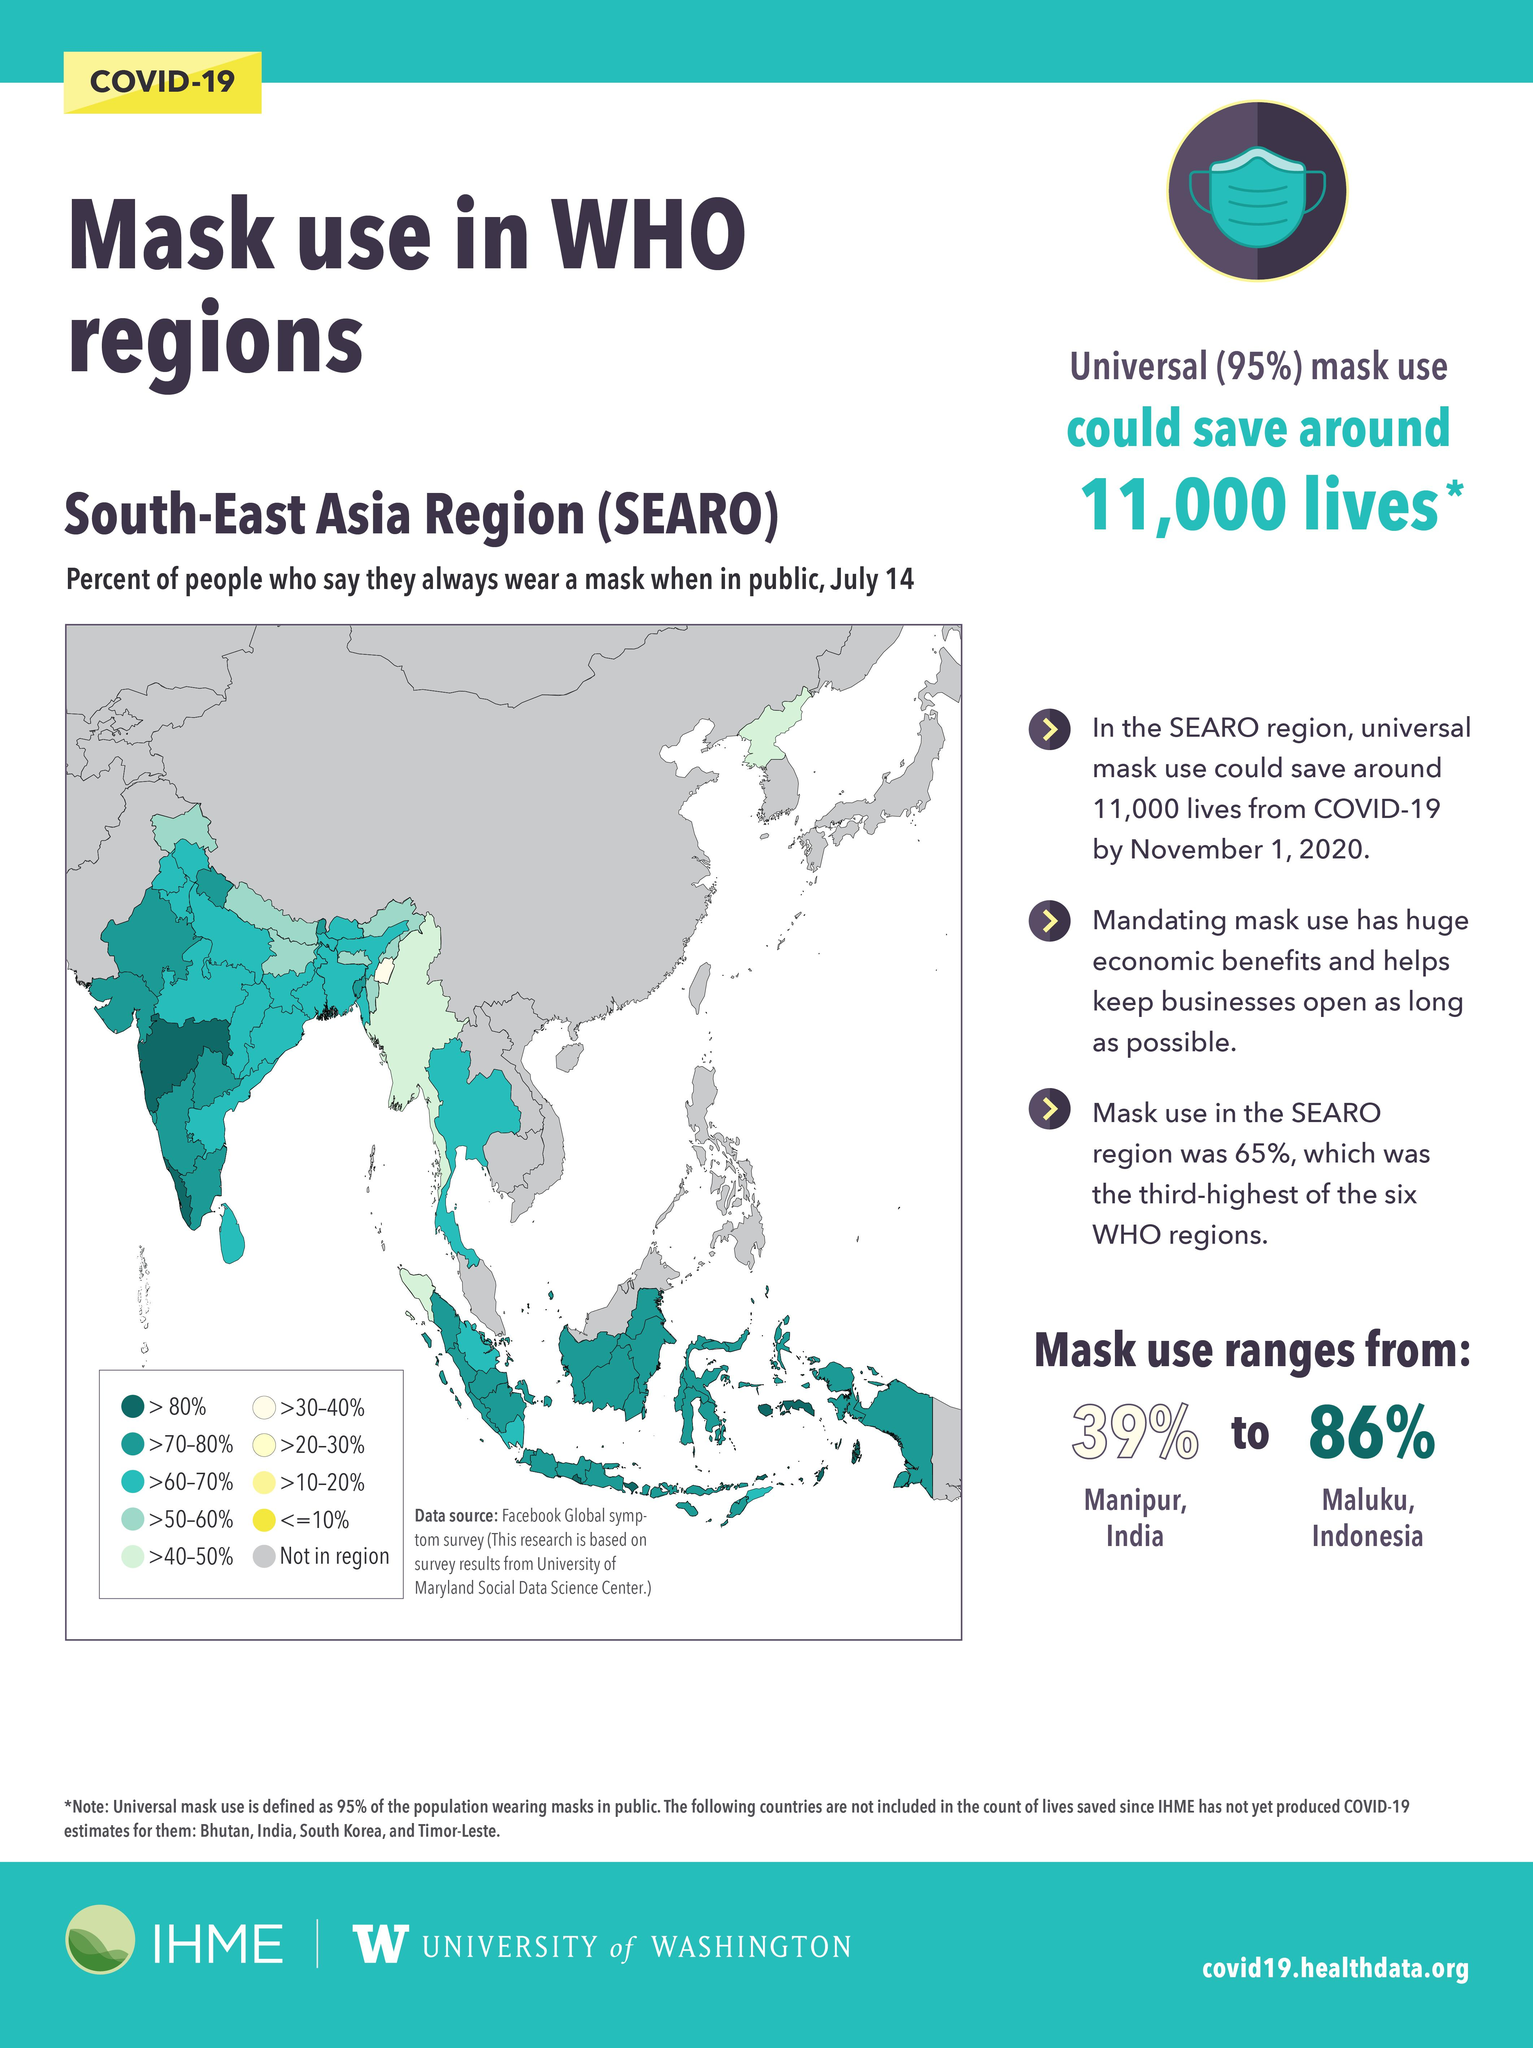Indicate a few pertinent items in this graphic. In Manipur, the usage of face masks is reported to be 39%. According to a survey in Maluku, Indonesia, mask usage is at 86%. In Indonesia, a country with a high percentage of mask usage is observed. A significant proportion of people in the left-most island region use masks. Over 60% to 70% of the population in this region wear masks to protect themselves from the spread of the virus. In Manipur, India, the region with the lowest percentage of mask usage is found. 